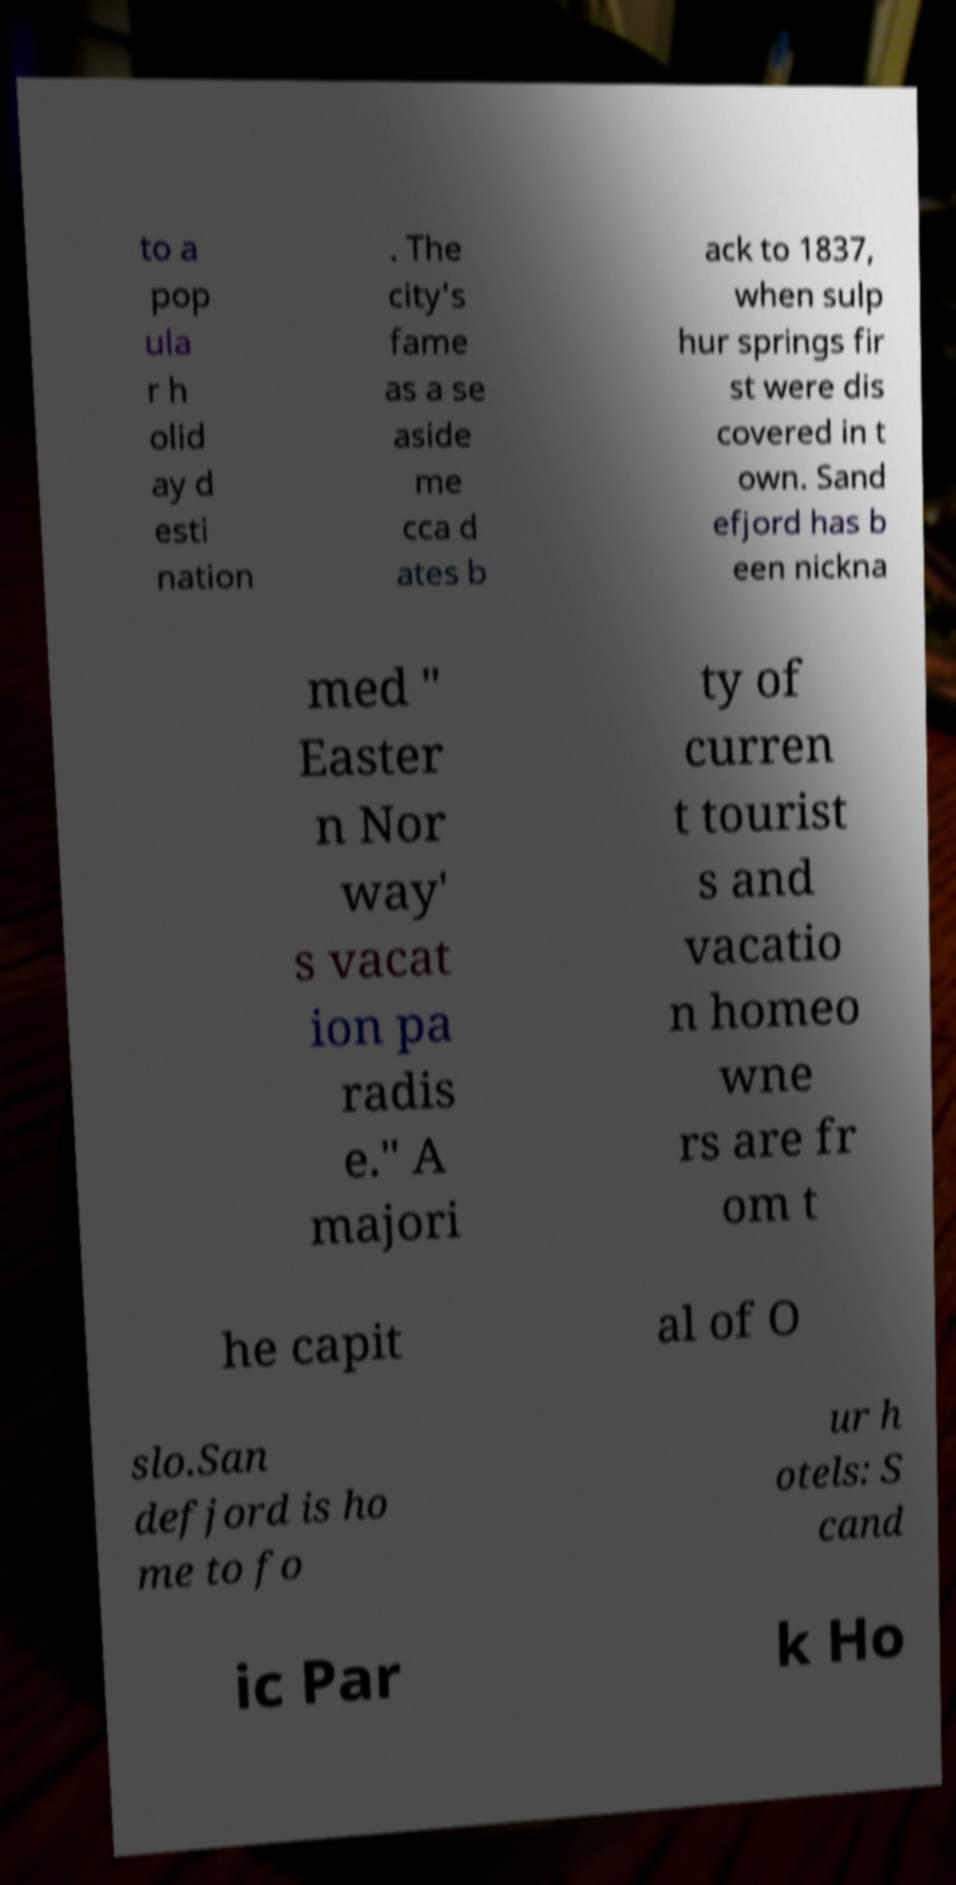Can you accurately transcribe the text from the provided image for me? to a pop ula r h olid ay d esti nation . The city's fame as a se aside me cca d ates b ack to 1837, when sulp hur springs fir st were dis covered in t own. Sand efjord has b een nickna med " Easter n Nor way' s vacat ion pa radis e." A majori ty of curren t tourist s and vacatio n homeo wne rs are fr om t he capit al of O slo.San defjord is ho me to fo ur h otels: S cand ic Par k Ho 